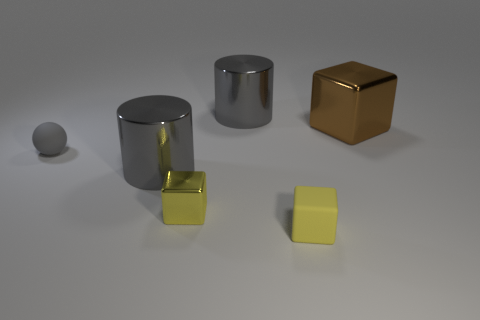Are there any other things that are the same shape as the small gray object?
Make the answer very short. No. What is the shape of the gray shiny object behind the big metal thing in front of the metallic cube that is behind the tiny matte sphere?
Your response must be concise. Cylinder. The yellow shiny thing has what size?
Your answer should be very brief. Small. Are there any other objects made of the same material as the small gray object?
Provide a succinct answer. Yes. What size is the yellow matte object that is the same shape as the tiny metallic object?
Give a very brief answer. Small. Is the number of small matte things to the left of the tiny yellow rubber thing the same as the number of gray rubber spheres?
Your response must be concise. Yes. There is a rubber thing that is in front of the small gray matte sphere; is it the same shape as the tiny yellow metal thing?
Your answer should be very brief. Yes. What shape is the big brown metallic object?
Keep it short and to the point. Cube. What material is the yellow block that is on the right side of the gray metal thing right of the tiny yellow metal object that is in front of the tiny gray matte ball?
Make the answer very short. Rubber. There is a small thing that is the same color as the small metal block; what is it made of?
Make the answer very short. Rubber. 